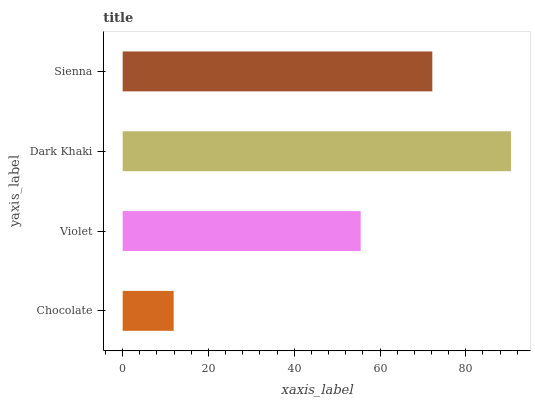Is Chocolate the minimum?
Answer yes or no. Yes. Is Dark Khaki the maximum?
Answer yes or no. Yes. Is Violet the minimum?
Answer yes or no. No. Is Violet the maximum?
Answer yes or no. No. Is Violet greater than Chocolate?
Answer yes or no. Yes. Is Chocolate less than Violet?
Answer yes or no. Yes. Is Chocolate greater than Violet?
Answer yes or no. No. Is Violet less than Chocolate?
Answer yes or no. No. Is Sienna the high median?
Answer yes or no. Yes. Is Violet the low median?
Answer yes or no. Yes. Is Chocolate the high median?
Answer yes or no. No. Is Chocolate the low median?
Answer yes or no. No. 